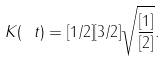<formula> <loc_0><loc_0><loc_500><loc_500>K ( \ t ) = [ 1 / 2 ] [ 3 / 2 ] \sqrt { \frac { [ 1 ] } { [ 2 ] } } .</formula> 